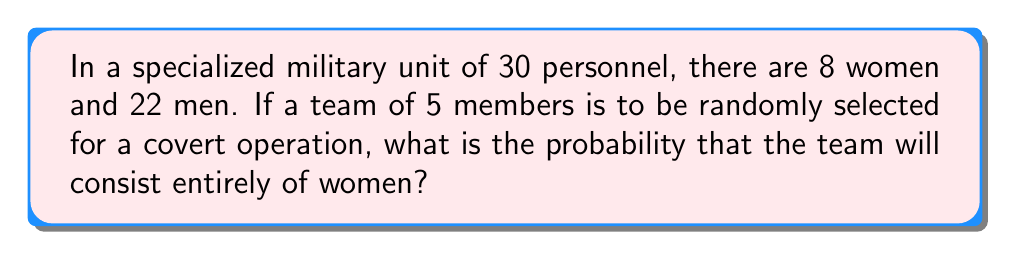What is the answer to this math problem? To solve this problem, we'll use the concept of combinations and the probability formula:

1) First, we need to calculate the number of ways to select 5 women from 8:
   $${8 \choose 5} = \frac{8!}{5!(8-5)!} = \frac{8!}{5!3!} = 56$$

2) Next, we calculate the total number of ways to select 5 people from 30:
   $${30 \choose 5} = \frac{30!}{5!(30-5)!} = \frac{30!}{5!25!} = 142,506$$

3) The probability is then the number of favorable outcomes divided by the total number of possible outcomes:

   $$P(\text{all-female team}) = \frac{{8 \choose 5}}{{30 \choose 5}} = \frac{56}{142,506}$$

4) Simplifying this fraction:
   $$\frac{56}{142,506} = \frac{28}{71,253} \approx 0.000393$$

5) Converting to a percentage:
   $$0.000393 \times 100\% \approx 0.0393\%$$
Answer: $\frac{28}{71,253}$ or approximately $0.0393\%$ 